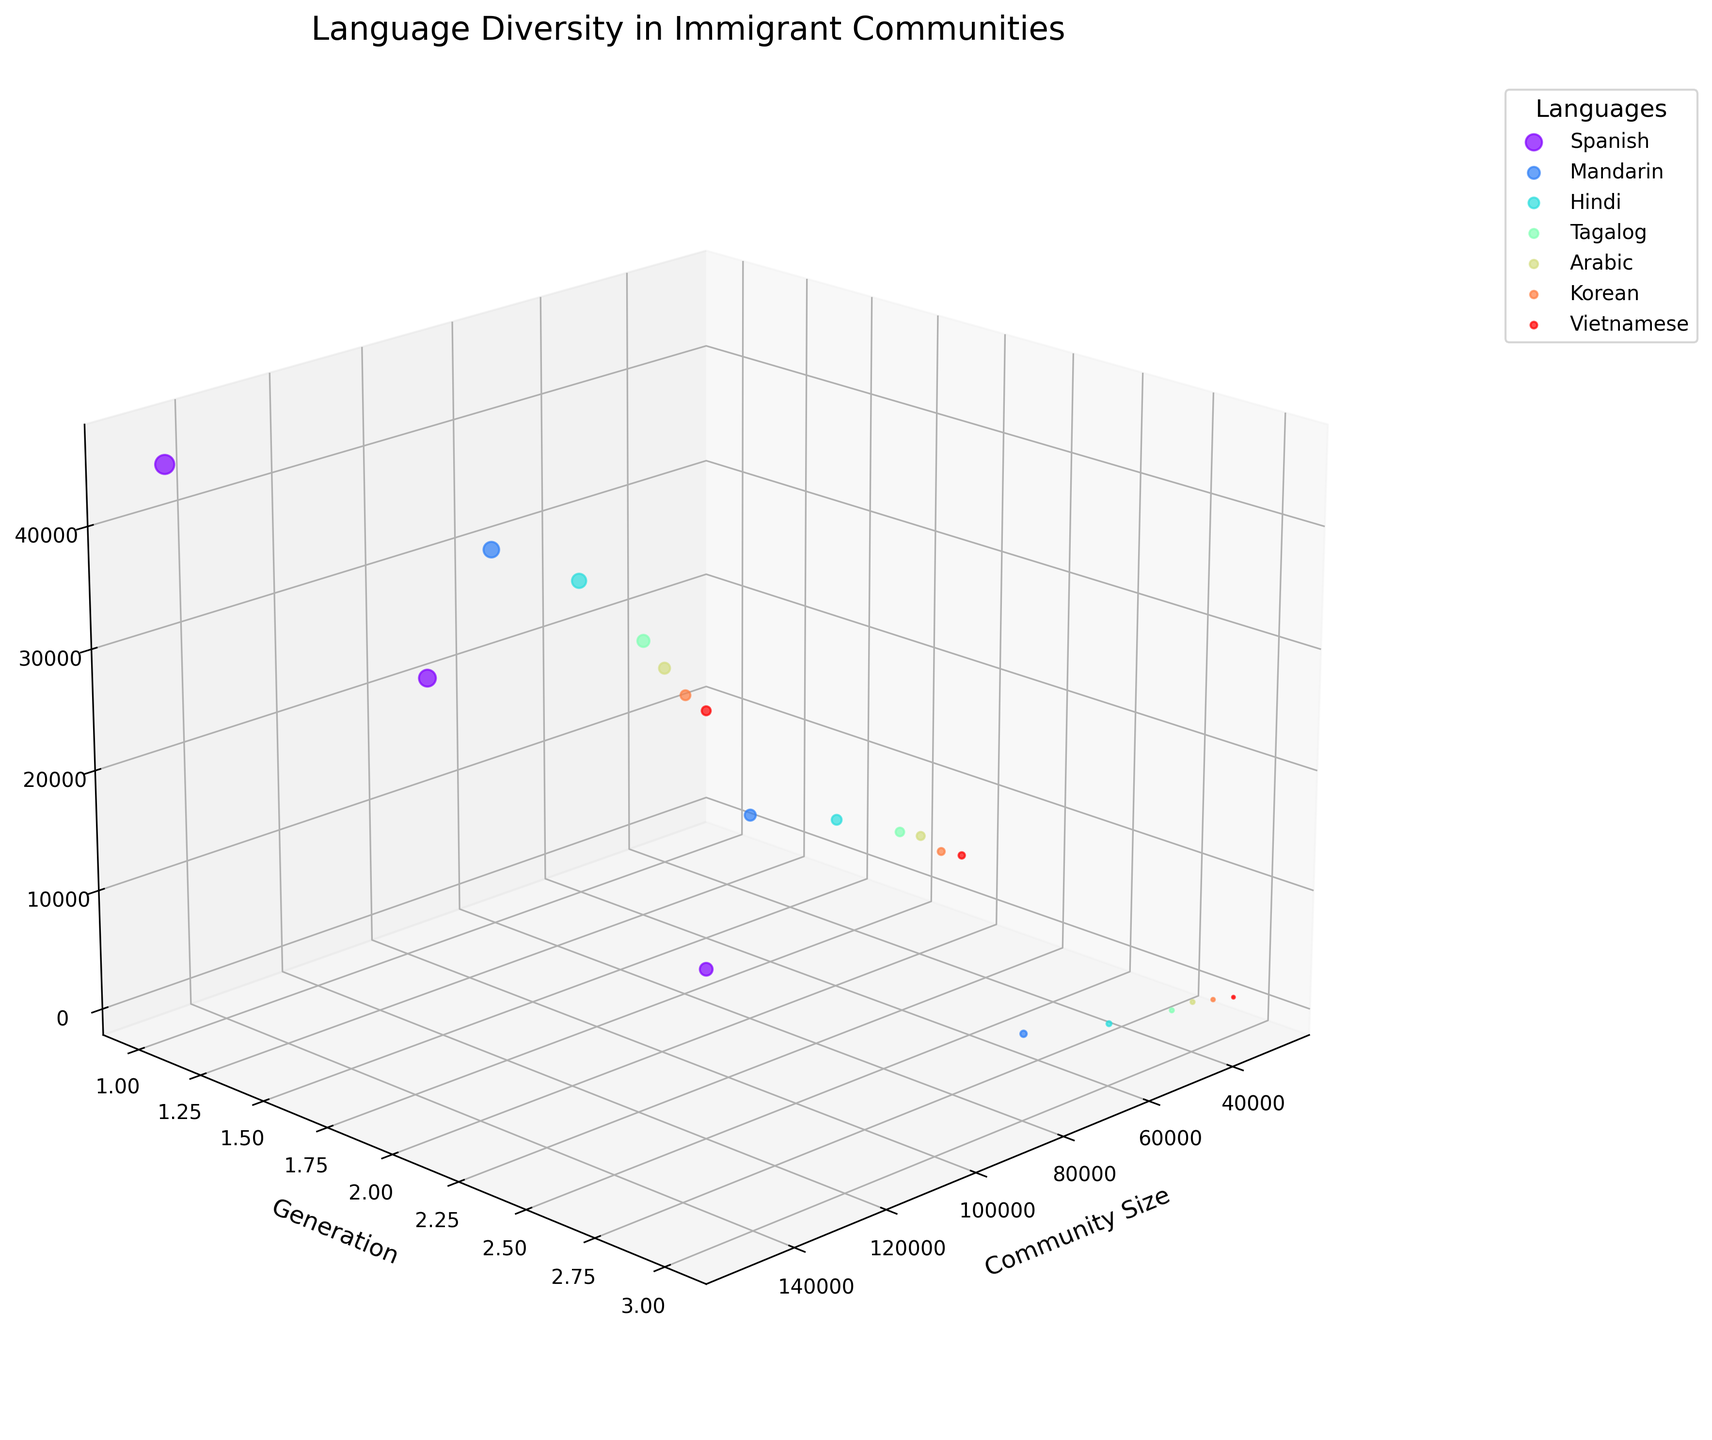What is the title of the plot? The title of the plot is displayed at the top and is meant to provide an overview of what the plot represents. In this case, it’s clearly stated at the top of the figure.
Answer: Language Diversity in Immigrant Communities What are the labels of the axes? The labels of the axes are identified near the corresponding axes and describe what each axis represents. Here, the x-axis is labeled 'Community Size,' the y-axis is labeled 'Generation,' and the z-axis is labeled 'Number of Speakers'.
Answer: Community Size, Generation, Number of Speakers Which language has the largest community size? The largest community size can be determined by looking at the data points positioned farthest along the x-axis. Spanish has the data points at the highest x-value, which is 150,000 in each generation.
Answer: Spanish How does the number of Mandarin speakers change across generations? To understand this, we need to follow the Mandarin data points across the generations on the y-axis. The z-values (number of speakers) for Mandarin decrease as the generation number (y-value) increases: 1st generation - 30,000, 2nd generation - 15,000, 3rd generation - 5,000.
Answer: Decreases For which language does the number of speakers decrease the most from the 1st to the 3rd generation? Comparing the decrease in the number of speakers from the 1st to the 3rd generations for each language: Spanish (45,000 to 20,000), Mandarin (30,000 to 5,000), Hindi (25,000 to 3,000), Tagalog (18,000 to 2,000), Arabic (15,000 to 2,000), Korean (12,000 to 1,500), Vietnamese (10,000 to 1,000). The largest decrease is for Mandarin, from 30,000 to 5,000.
Answer: Mandarin Which language has the smallest community size? Community size is shown on the x-axis. The smallest one is indicated by the smallest x-values, which is seen in the Vietnamese data points at 30,000.
Answer: Vietnamese Comparing the second-generation speakers, which language has a higher number of speakers, Tagalog or Korean? For this, we look at the 2nd generation (y=2) data points for Tagalog and Korean. The z-values (number of speakers) for Tagalog is 9,000 and for Korean, it’s 6,000. 9,000 is greater than 6,000.
Answer: Tagalog What trend can you see in the number of Hindi speakers across generations? Observing the Hindi data points across the generations along the y-axis (1, 2, 3), the z-values (number of speakers) show a declining trend: 25,000 for 1st generation, 12,000 for 2nd generation, 3,000 for 3rd generation.
Answer: Decreasing trend 